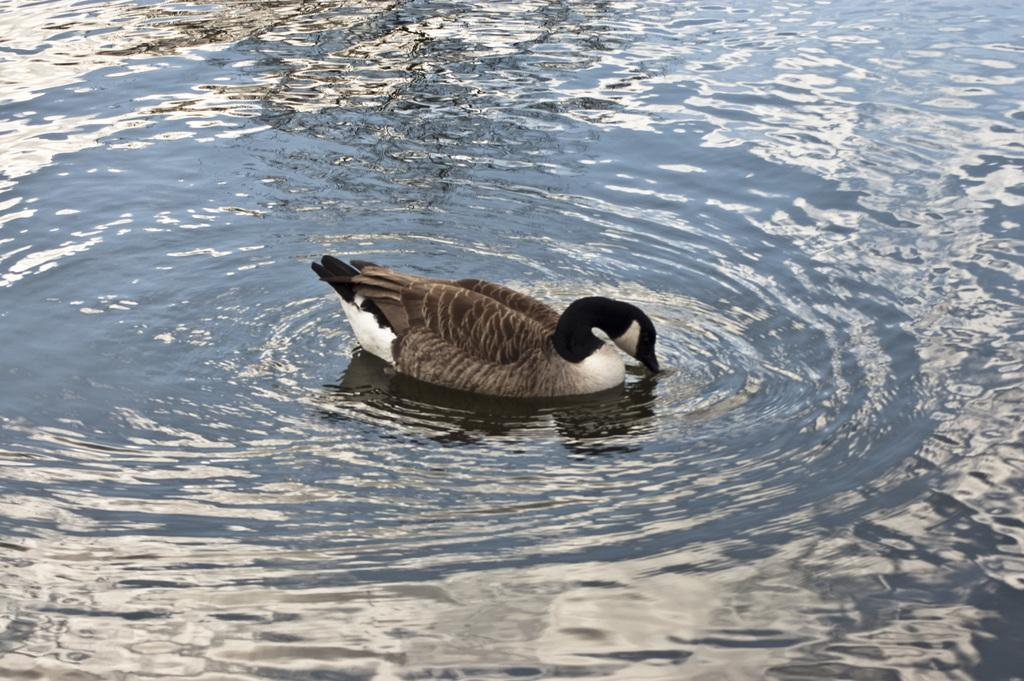What is visible in the image? There is water visible in the image. Are there any animals present in the water? Yes, there is a duck in the water. What type of shock can be seen in the image? There is no shock present in the image; it features water and a duck. Can you see a plane in the image? No, there is no plane visible in the image. 